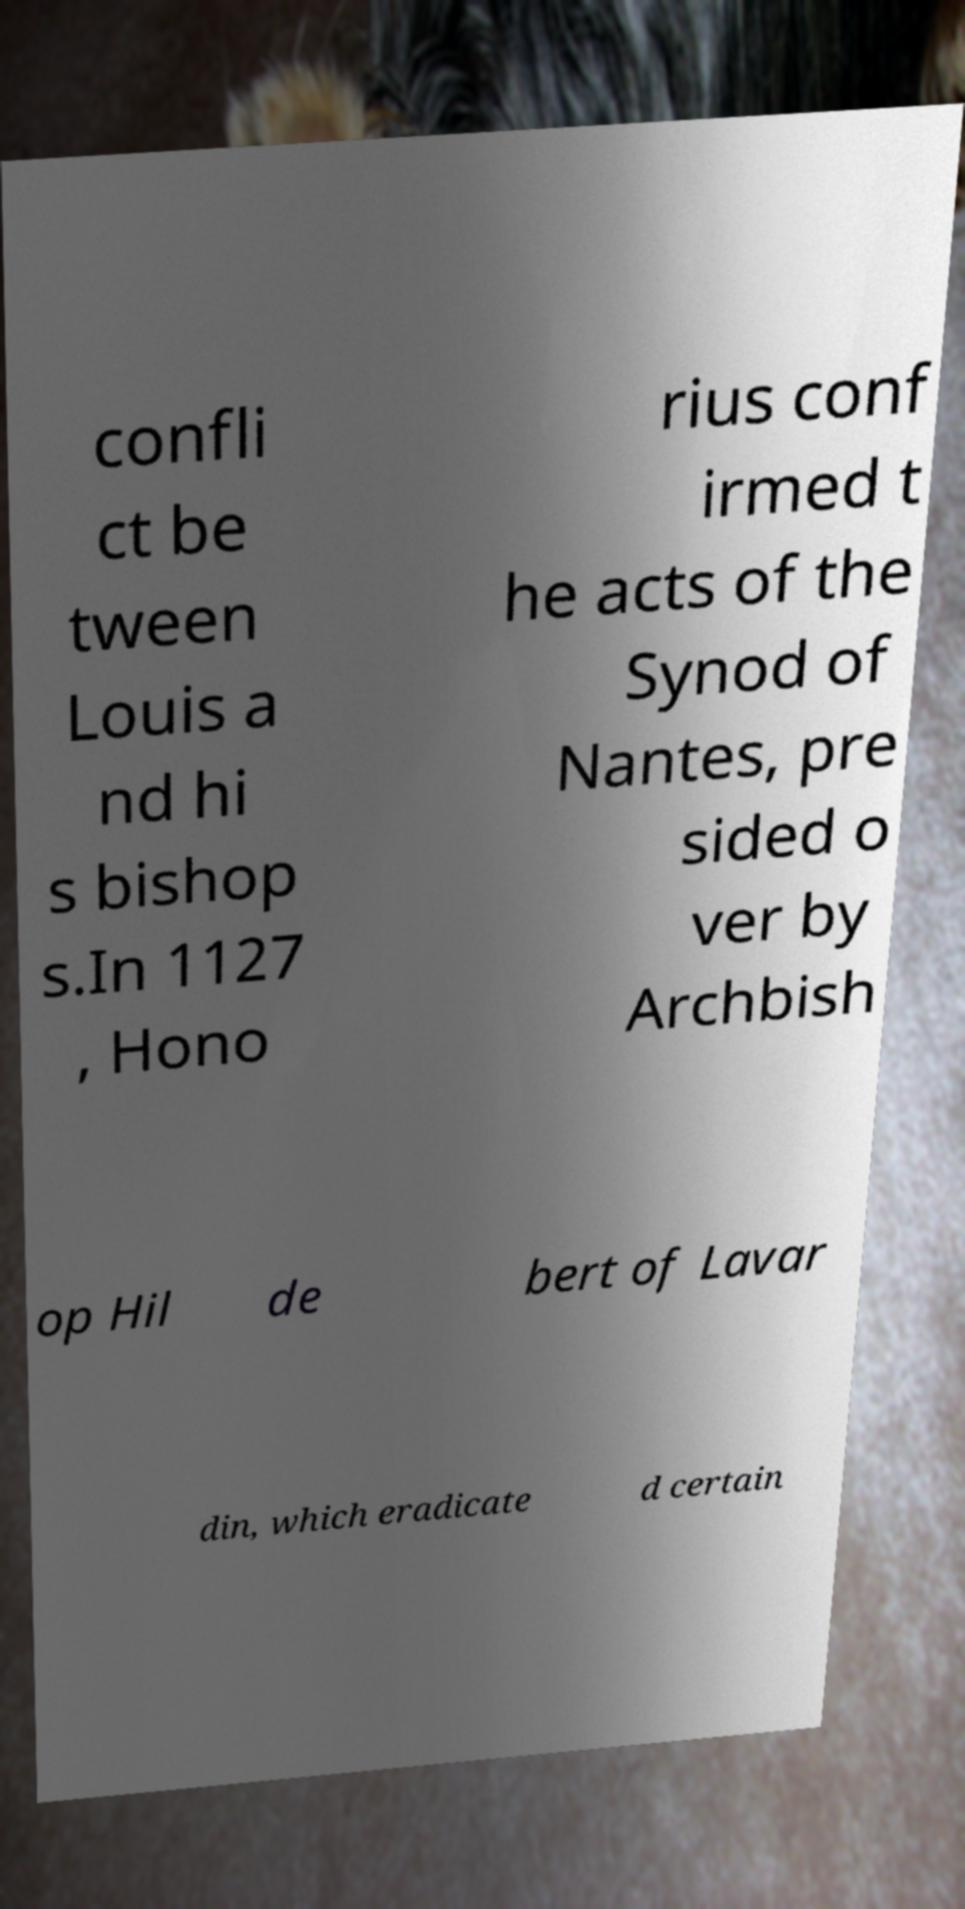Please read and relay the text visible in this image. What does it say? confli ct be tween Louis a nd hi s bishop s.In 1127 , Hono rius conf irmed t he acts of the Synod of Nantes, pre sided o ver by Archbish op Hil de bert of Lavar din, which eradicate d certain 